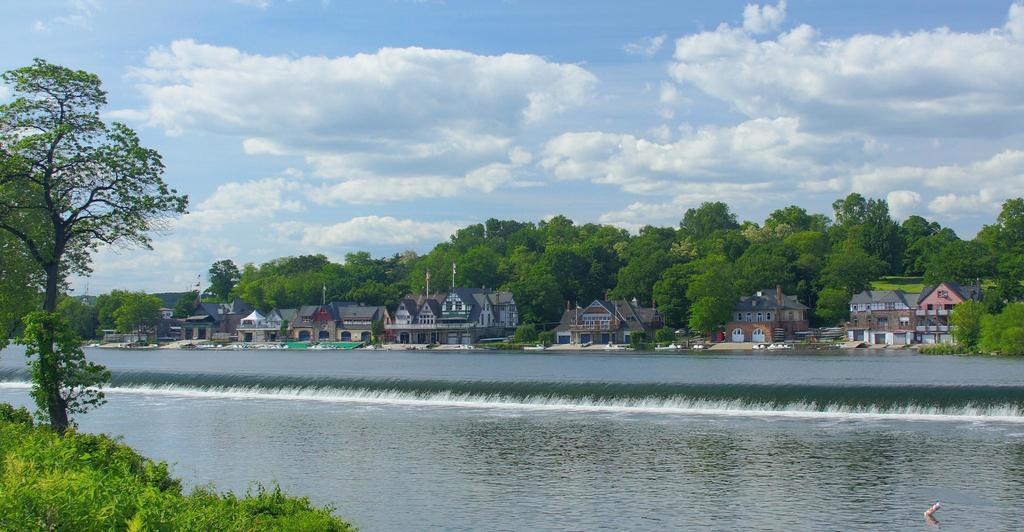What type of vegetation is present on the ground in the front of the image? There is grass on the ground in the front of the image. What other natural element can be seen in the front of the image? There is a tree in the front of the image. What is the main feature in the center of the image? There is water in the center of the image. What can be seen in the background of the image? There are buildings and trees in the background of the image. How would you describe the sky in the background of the image? The sky is cloudy in the background of the image. What type of angle is being used to view the territory in the image? The image does not depict a specific angle or territory; it shows a scene with grass, a tree, water, buildings, trees, and a cloudy sky. What type of feast is being prepared in the background of the image? There is no feast or preparation for a feast visible in the image. 